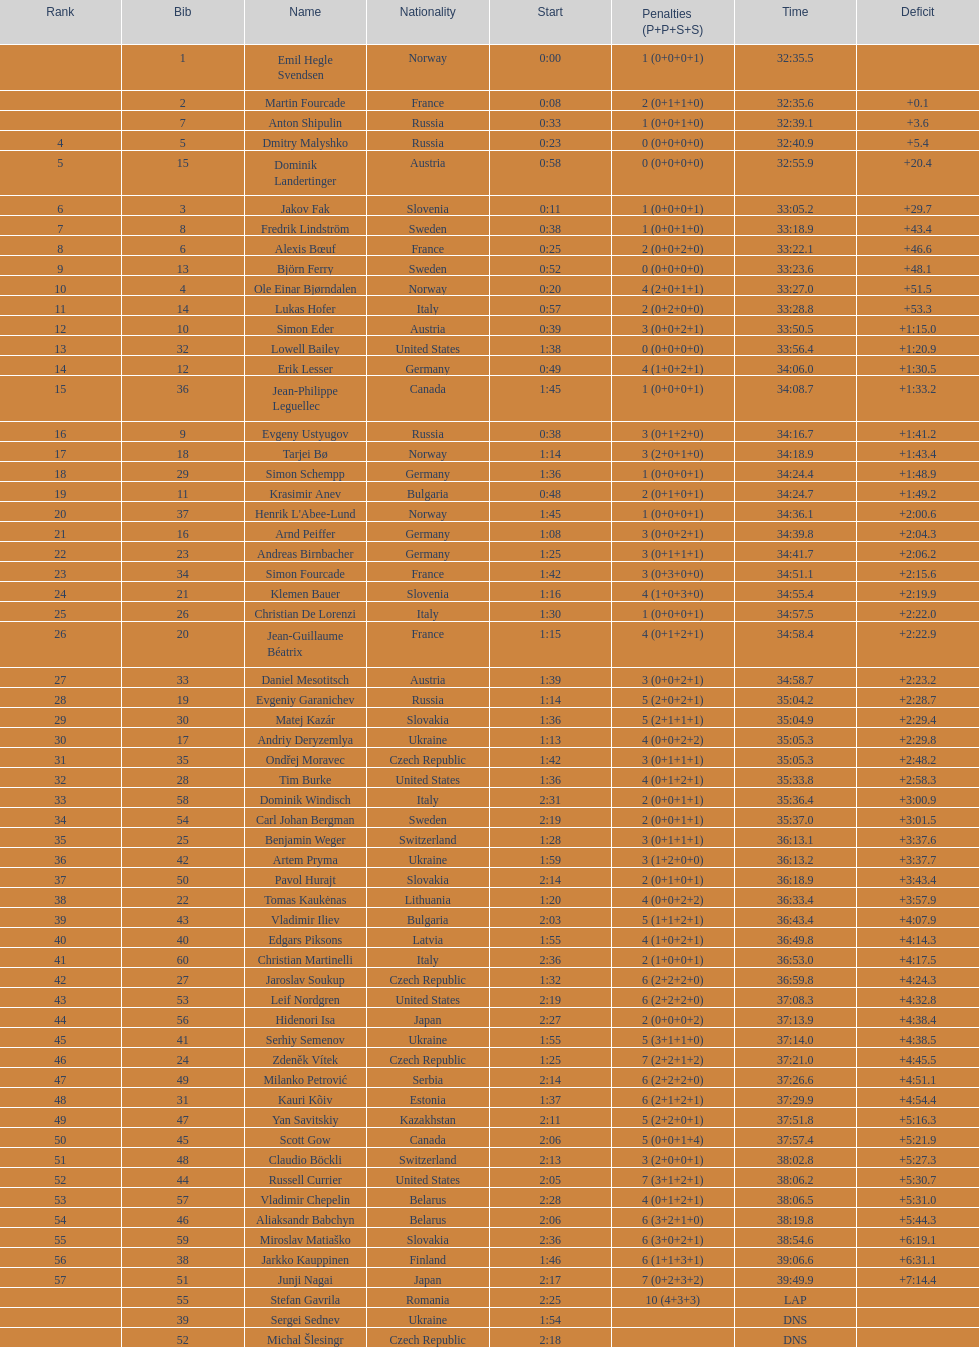Can you provide the name of an american athlete other than burke? Leif Nordgren. I'm looking to parse the entire table for insights. Could you assist me with that? {'header': ['Rank', 'Bib', 'Name', 'Nationality', 'Start', 'Penalties (P+P+S+S)', 'Time', 'Deficit'], 'rows': [['', '1', 'Emil Hegle Svendsen', 'Norway', '0:00', '1 (0+0+0+1)', '32:35.5', ''], ['', '2', 'Martin Fourcade', 'France', '0:08', '2 (0+1+1+0)', '32:35.6', '+0.1'], ['', '7', 'Anton Shipulin', 'Russia', '0:33', '1 (0+0+1+0)', '32:39.1', '+3.6'], ['4', '5', 'Dmitry Malyshko', 'Russia', '0:23', '0 (0+0+0+0)', '32:40.9', '+5.4'], ['5', '15', 'Dominik Landertinger', 'Austria', '0:58', '0 (0+0+0+0)', '32:55.9', '+20.4'], ['6', '3', 'Jakov Fak', 'Slovenia', '0:11', '1 (0+0+0+1)', '33:05.2', '+29.7'], ['7', '8', 'Fredrik Lindström', 'Sweden', '0:38', '1 (0+0+1+0)', '33:18.9', '+43.4'], ['8', '6', 'Alexis Bœuf', 'France', '0:25', '2 (0+0+2+0)', '33:22.1', '+46.6'], ['9', '13', 'Björn Ferry', 'Sweden', '0:52', '0 (0+0+0+0)', '33:23.6', '+48.1'], ['10', '4', 'Ole Einar Bjørndalen', 'Norway', '0:20', '4 (2+0+1+1)', '33:27.0', '+51.5'], ['11', '14', 'Lukas Hofer', 'Italy', '0:57', '2 (0+2+0+0)', '33:28.8', '+53.3'], ['12', '10', 'Simon Eder', 'Austria', '0:39', '3 (0+0+2+1)', '33:50.5', '+1:15.0'], ['13', '32', 'Lowell Bailey', 'United States', '1:38', '0 (0+0+0+0)', '33:56.4', '+1:20.9'], ['14', '12', 'Erik Lesser', 'Germany', '0:49', '4 (1+0+2+1)', '34:06.0', '+1:30.5'], ['15', '36', 'Jean-Philippe Leguellec', 'Canada', '1:45', '1 (0+0+0+1)', '34:08.7', '+1:33.2'], ['16', '9', 'Evgeny Ustyugov', 'Russia', '0:38', '3 (0+1+2+0)', '34:16.7', '+1:41.2'], ['17', '18', 'Tarjei Bø', 'Norway', '1:14', '3 (2+0+1+0)', '34:18.9', '+1:43.4'], ['18', '29', 'Simon Schempp', 'Germany', '1:36', '1 (0+0+0+1)', '34:24.4', '+1:48.9'], ['19', '11', 'Krasimir Anev', 'Bulgaria', '0:48', '2 (0+1+0+1)', '34:24.7', '+1:49.2'], ['20', '37', "Henrik L'Abee-Lund", 'Norway', '1:45', '1 (0+0+0+1)', '34:36.1', '+2:00.6'], ['21', '16', 'Arnd Peiffer', 'Germany', '1:08', '3 (0+0+2+1)', '34:39.8', '+2:04.3'], ['22', '23', 'Andreas Birnbacher', 'Germany', '1:25', '3 (0+1+1+1)', '34:41.7', '+2:06.2'], ['23', '34', 'Simon Fourcade', 'France', '1:42', '3 (0+3+0+0)', '34:51.1', '+2:15.6'], ['24', '21', 'Klemen Bauer', 'Slovenia', '1:16', '4 (1+0+3+0)', '34:55.4', '+2:19.9'], ['25', '26', 'Christian De Lorenzi', 'Italy', '1:30', '1 (0+0+0+1)', '34:57.5', '+2:22.0'], ['26', '20', 'Jean-Guillaume Béatrix', 'France', '1:15', '4 (0+1+2+1)', '34:58.4', '+2:22.9'], ['27', '33', 'Daniel Mesotitsch', 'Austria', '1:39', '3 (0+0+2+1)', '34:58.7', '+2:23.2'], ['28', '19', 'Evgeniy Garanichev', 'Russia', '1:14', '5 (2+0+2+1)', '35:04.2', '+2:28.7'], ['29', '30', 'Matej Kazár', 'Slovakia', '1:36', '5 (2+1+1+1)', '35:04.9', '+2:29.4'], ['30', '17', 'Andriy Deryzemlya', 'Ukraine', '1:13', '4 (0+0+2+2)', '35:05.3', '+2:29.8'], ['31', '35', 'Ondřej Moravec', 'Czech Republic', '1:42', '3 (0+1+1+1)', '35:05.3', '+2:48.2'], ['32', '28', 'Tim Burke', 'United States', '1:36', '4 (0+1+2+1)', '35:33.8', '+2:58.3'], ['33', '58', 'Dominik Windisch', 'Italy', '2:31', '2 (0+0+1+1)', '35:36.4', '+3:00.9'], ['34', '54', 'Carl Johan Bergman', 'Sweden', '2:19', '2 (0+0+1+1)', '35:37.0', '+3:01.5'], ['35', '25', 'Benjamin Weger', 'Switzerland', '1:28', '3 (0+1+1+1)', '36:13.1', '+3:37.6'], ['36', '42', 'Artem Pryma', 'Ukraine', '1:59', '3 (1+2+0+0)', '36:13.2', '+3:37.7'], ['37', '50', 'Pavol Hurajt', 'Slovakia', '2:14', '2 (0+1+0+1)', '36:18.9', '+3:43.4'], ['38', '22', 'Tomas Kaukėnas', 'Lithuania', '1:20', '4 (0+0+2+2)', '36:33.4', '+3:57.9'], ['39', '43', 'Vladimir Iliev', 'Bulgaria', '2:03', '5 (1+1+2+1)', '36:43.4', '+4:07.9'], ['40', '40', 'Edgars Piksons', 'Latvia', '1:55', '4 (1+0+2+1)', '36:49.8', '+4:14.3'], ['41', '60', 'Christian Martinelli', 'Italy', '2:36', '2 (1+0+0+1)', '36:53.0', '+4:17.5'], ['42', '27', 'Jaroslav Soukup', 'Czech Republic', '1:32', '6 (2+2+2+0)', '36:59.8', '+4:24.3'], ['43', '53', 'Leif Nordgren', 'United States', '2:19', '6 (2+2+2+0)', '37:08.3', '+4:32.8'], ['44', '56', 'Hidenori Isa', 'Japan', '2:27', '2 (0+0+0+2)', '37:13.9', '+4:38.4'], ['45', '41', 'Serhiy Semenov', 'Ukraine', '1:55', '5 (3+1+1+0)', '37:14.0', '+4:38.5'], ['46', '24', 'Zdeněk Vítek', 'Czech Republic', '1:25', '7 (2+2+1+2)', '37:21.0', '+4:45.5'], ['47', '49', 'Milanko Petrović', 'Serbia', '2:14', '6 (2+2+2+0)', '37:26.6', '+4:51.1'], ['48', '31', 'Kauri Kõiv', 'Estonia', '1:37', '6 (2+1+2+1)', '37:29.9', '+4:54.4'], ['49', '47', 'Yan Savitskiy', 'Kazakhstan', '2:11', '5 (2+2+0+1)', '37:51.8', '+5:16.3'], ['50', '45', 'Scott Gow', 'Canada', '2:06', '5 (0+0+1+4)', '37:57.4', '+5:21.9'], ['51', '48', 'Claudio Böckli', 'Switzerland', '2:13', '3 (2+0+0+1)', '38:02.8', '+5:27.3'], ['52', '44', 'Russell Currier', 'United States', '2:05', '7 (3+1+2+1)', '38:06.2', '+5:30.7'], ['53', '57', 'Vladimir Chepelin', 'Belarus', '2:28', '4 (0+1+2+1)', '38:06.5', '+5:31.0'], ['54', '46', 'Aliaksandr Babchyn', 'Belarus', '2:06', '6 (3+2+1+0)', '38:19.8', '+5:44.3'], ['55', '59', 'Miroslav Matiaško', 'Slovakia', '2:36', '6 (3+0+2+1)', '38:54.6', '+6:19.1'], ['56', '38', 'Jarkko Kauppinen', 'Finland', '1:46', '6 (1+1+3+1)', '39:06.6', '+6:31.1'], ['57', '51', 'Junji Nagai', 'Japan', '2:17', '7 (0+2+3+2)', '39:49.9', '+7:14.4'], ['', '55', 'Stefan Gavrila', 'Romania', '2:25', '10 (4+3+3)', 'LAP', ''], ['', '39', 'Sergei Sednev', 'Ukraine', '1:54', '', 'DNS', ''], ['', '52', 'Michal Šlesingr', 'Czech Republic', '2:18', '', 'DNS', '']]} 